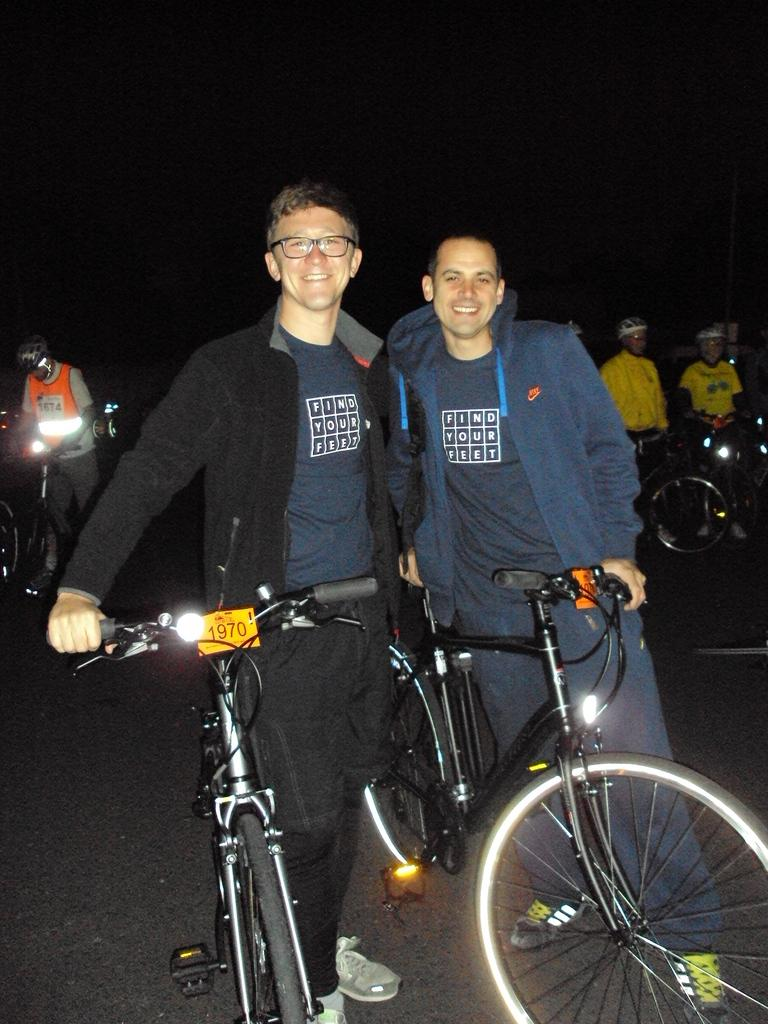How many men are present in the image? There are two men in the image. What are the men wearing? The men are wearing jackets. What are the men holding in the image? The men are holding bicycles. Where does the scene take place? The scene takes place on a road. How many other people are visible in the image? There are three other people in the background of the image. What are these people holding? These people are also holding bicycles. Can you describe the lighting in the image? The image appears to be dark. Can you see a quill being used by one of the men in the image? No, there is no quill present in the image. What suggestion is being made by the men in the image? The image does not depict any suggestions being made; it simply shows men holding bicycles. 